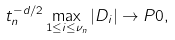<formula> <loc_0><loc_0><loc_500><loc_500>t _ { n } ^ { - d / 2 } \max _ { 1 \leq i \leq \nu _ { n } } | D _ { i } | \to P 0 ,</formula> 